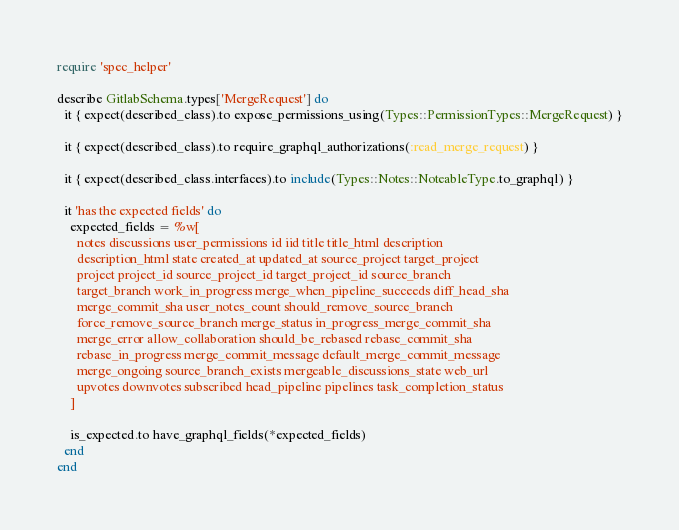Convert code to text. <code><loc_0><loc_0><loc_500><loc_500><_Ruby_>require 'spec_helper'

describe GitlabSchema.types['MergeRequest'] do
  it { expect(described_class).to expose_permissions_using(Types::PermissionTypes::MergeRequest) }

  it { expect(described_class).to require_graphql_authorizations(:read_merge_request) }

  it { expect(described_class.interfaces).to include(Types::Notes::NoteableType.to_graphql) }

  it 'has the expected fields' do
    expected_fields = %w[
      notes discussions user_permissions id iid title title_html description
      description_html state created_at updated_at source_project target_project
      project project_id source_project_id target_project_id source_branch
      target_branch work_in_progress merge_when_pipeline_succeeds diff_head_sha
      merge_commit_sha user_notes_count should_remove_source_branch
      force_remove_source_branch merge_status in_progress_merge_commit_sha
      merge_error allow_collaboration should_be_rebased rebase_commit_sha
      rebase_in_progress merge_commit_message default_merge_commit_message
      merge_ongoing source_branch_exists mergeable_discussions_state web_url
      upvotes downvotes subscribed head_pipeline pipelines task_completion_status
    ]

    is_expected.to have_graphql_fields(*expected_fields)
  end
end
</code> 